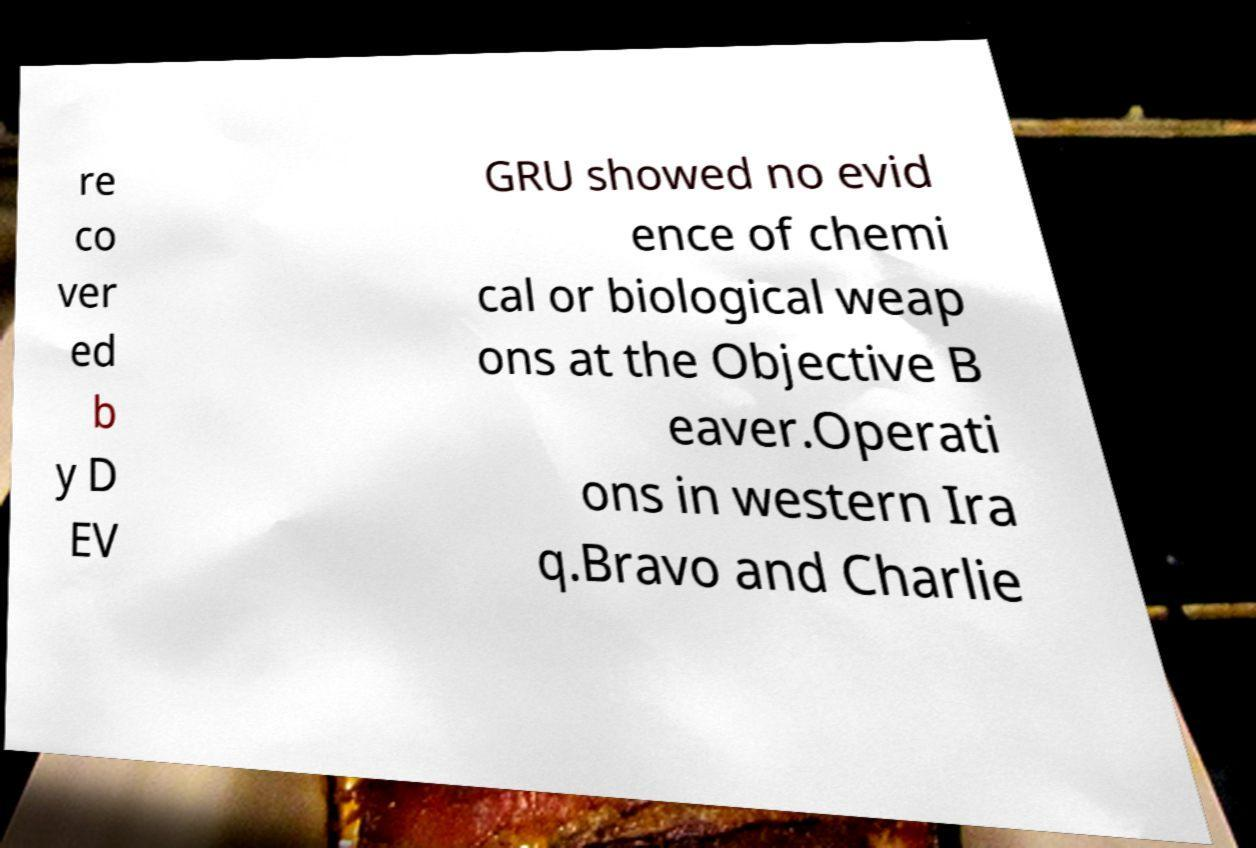Can you read and provide the text displayed in the image?This photo seems to have some interesting text. Can you extract and type it out for me? re co ver ed b y D EV GRU showed no evid ence of chemi cal or biological weap ons at the Objective B eaver.Operati ons in western Ira q.Bravo and Charlie 